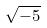Convert formula to latex. <formula><loc_0><loc_0><loc_500><loc_500>\sqrt { - 5 }</formula> 